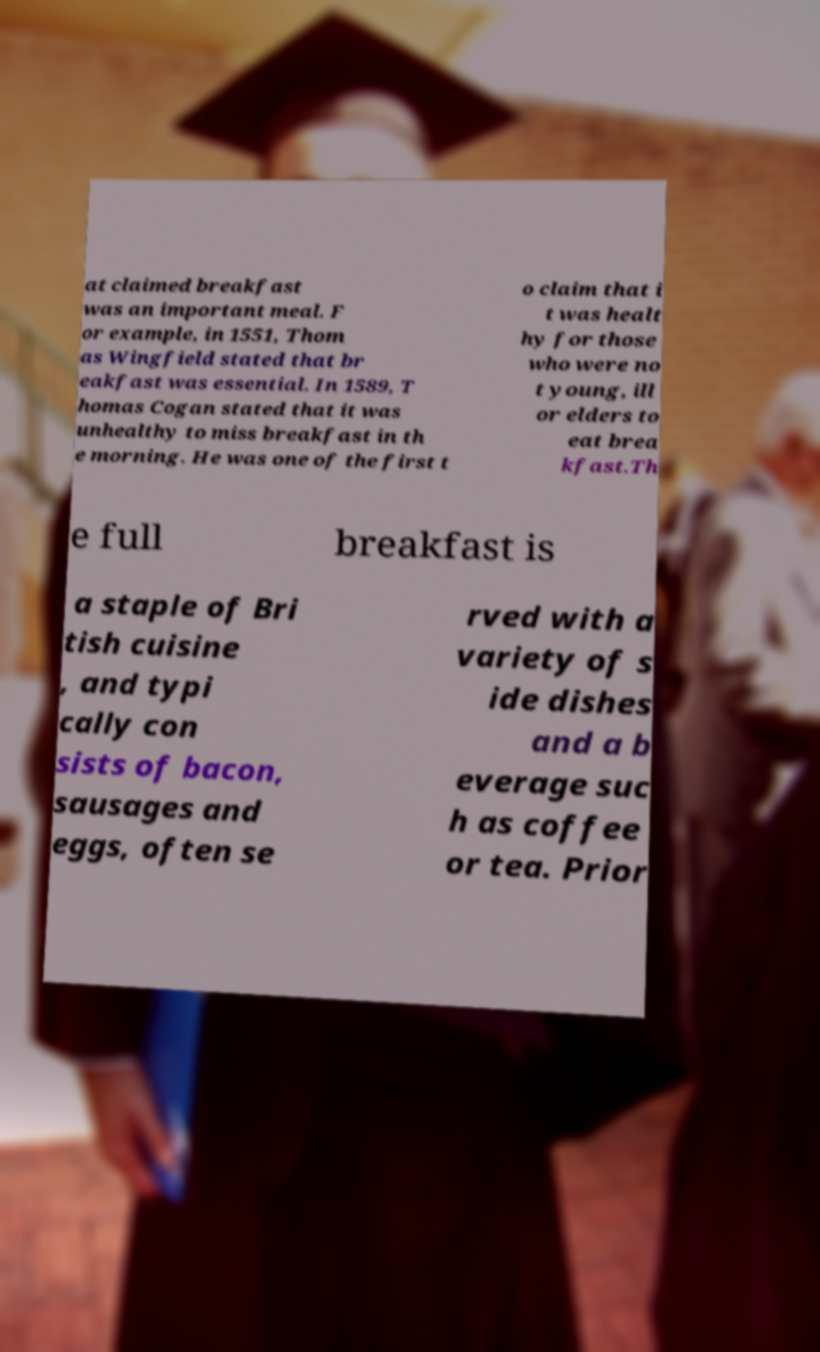Could you extract and type out the text from this image? at claimed breakfast was an important meal. F or example, in 1551, Thom as Wingfield stated that br eakfast was essential. In 1589, T homas Cogan stated that it was unhealthy to miss breakfast in th e morning. He was one of the first t o claim that i t was healt hy for those who were no t young, ill or elders to eat brea kfast.Th e full breakfast is a staple of Bri tish cuisine , and typi cally con sists of bacon, sausages and eggs, often se rved with a variety of s ide dishes and a b everage suc h as coffee or tea. Prior 